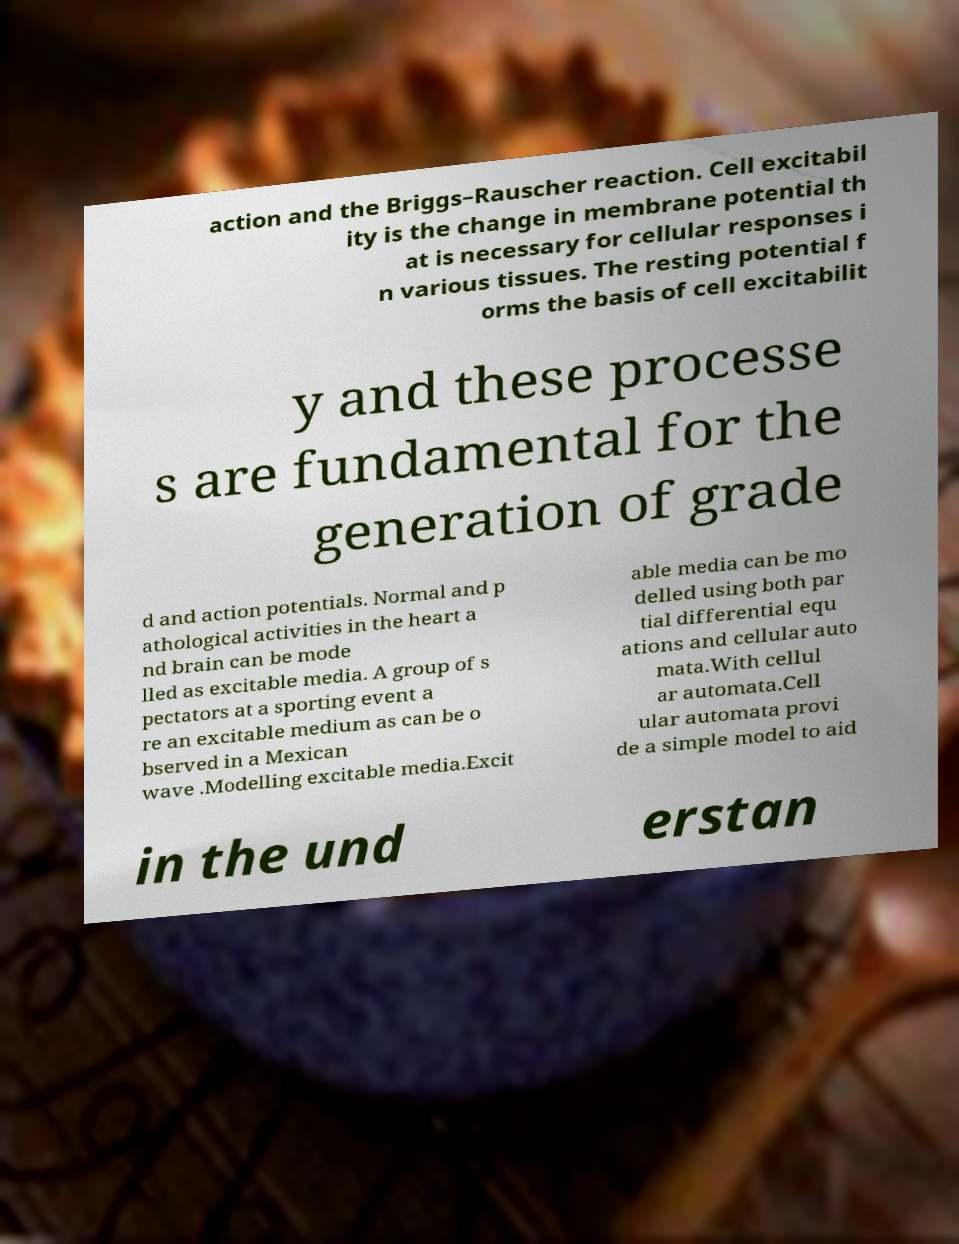Please read and relay the text visible in this image. What does it say? action and the Briggs–Rauscher reaction. Cell excitabil ity is the change in membrane potential th at is necessary for cellular responses i n various tissues. The resting potential f orms the basis of cell excitabilit y and these processe s are fundamental for the generation of grade d and action potentials. Normal and p athological activities in the heart a nd brain can be mode lled as excitable media. A group of s pectators at a sporting event a re an excitable medium as can be o bserved in a Mexican wave .Modelling excitable media.Excit able media can be mo delled using both par tial differential equ ations and cellular auto mata.With cellul ar automata.Cell ular automata provi de a simple model to aid in the und erstan 